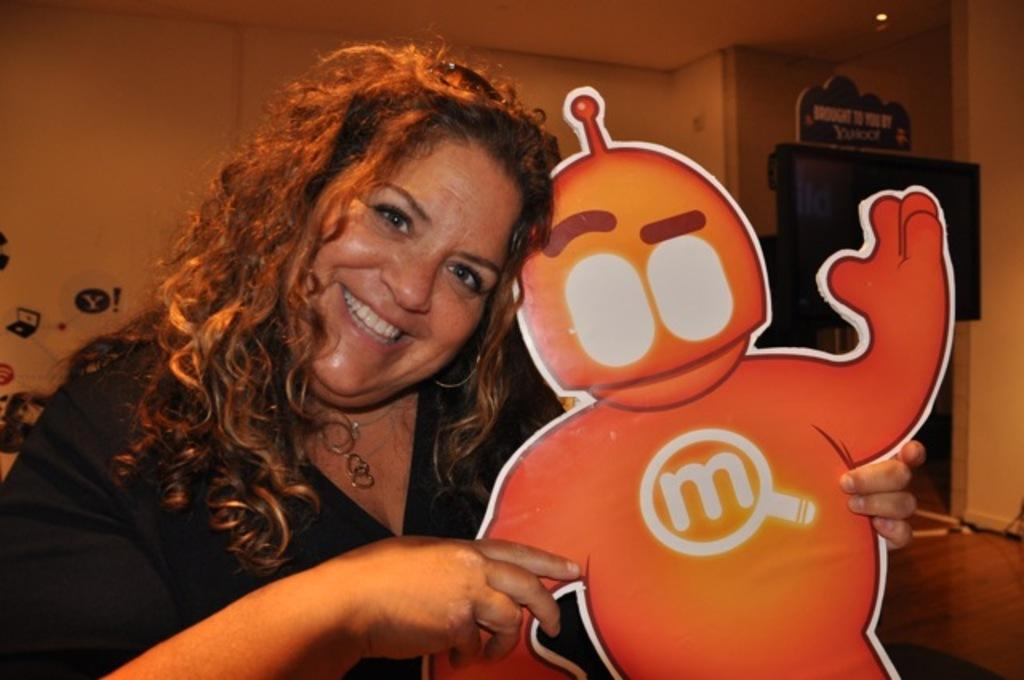<image>
Describe the image concisely. A girl is holding an orange figure with an M on it's chest. 